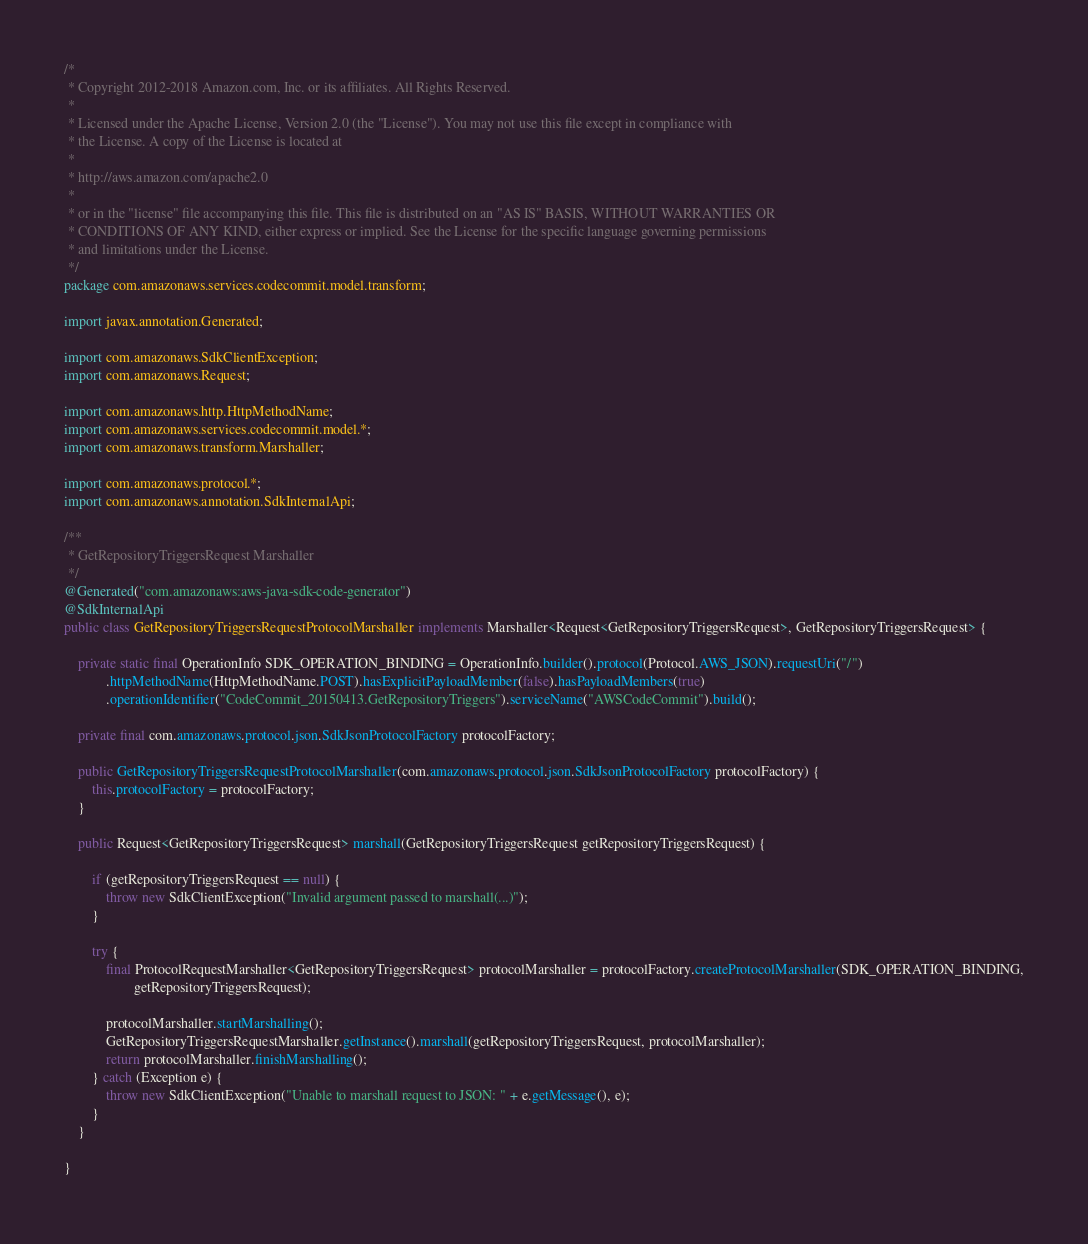Convert code to text. <code><loc_0><loc_0><loc_500><loc_500><_Java_>/*
 * Copyright 2012-2018 Amazon.com, Inc. or its affiliates. All Rights Reserved.
 * 
 * Licensed under the Apache License, Version 2.0 (the "License"). You may not use this file except in compliance with
 * the License. A copy of the License is located at
 * 
 * http://aws.amazon.com/apache2.0
 * 
 * or in the "license" file accompanying this file. This file is distributed on an "AS IS" BASIS, WITHOUT WARRANTIES OR
 * CONDITIONS OF ANY KIND, either express or implied. See the License for the specific language governing permissions
 * and limitations under the License.
 */
package com.amazonaws.services.codecommit.model.transform;

import javax.annotation.Generated;

import com.amazonaws.SdkClientException;
import com.amazonaws.Request;

import com.amazonaws.http.HttpMethodName;
import com.amazonaws.services.codecommit.model.*;
import com.amazonaws.transform.Marshaller;

import com.amazonaws.protocol.*;
import com.amazonaws.annotation.SdkInternalApi;

/**
 * GetRepositoryTriggersRequest Marshaller
 */
@Generated("com.amazonaws:aws-java-sdk-code-generator")
@SdkInternalApi
public class GetRepositoryTriggersRequestProtocolMarshaller implements Marshaller<Request<GetRepositoryTriggersRequest>, GetRepositoryTriggersRequest> {

    private static final OperationInfo SDK_OPERATION_BINDING = OperationInfo.builder().protocol(Protocol.AWS_JSON).requestUri("/")
            .httpMethodName(HttpMethodName.POST).hasExplicitPayloadMember(false).hasPayloadMembers(true)
            .operationIdentifier("CodeCommit_20150413.GetRepositoryTriggers").serviceName("AWSCodeCommit").build();

    private final com.amazonaws.protocol.json.SdkJsonProtocolFactory protocolFactory;

    public GetRepositoryTriggersRequestProtocolMarshaller(com.amazonaws.protocol.json.SdkJsonProtocolFactory protocolFactory) {
        this.protocolFactory = protocolFactory;
    }

    public Request<GetRepositoryTriggersRequest> marshall(GetRepositoryTriggersRequest getRepositoryTriggersRequest) {

        if (getRepositoryTriggersRequest == null) {
            throw new SdkClientException("Invalid argument passed to marshall(...)");
        }

        try {
            final ProtocolRequestMarshaller<GetRepositoryTriggersRequest> protocolMarshaller = protocolFactory.createProtocolMarshaller(SDK_OPERATION_BINDING,
                    getRepositoryTriggersRequest);

            protocolMarshaller.startMarshalling();
            GetRepositoryTriggersRequestMarshaller.getInstance().marshall(getRepositoryTriggersRequest, protocolMarshaller);
            return protocolMarshaller.finishMarshalling();
        } catch (Exception e) {
            throw new SdkClientException("Unable to marshall request to JSON: " + e.getMessage(), e);
        }
    }

}
</code> 